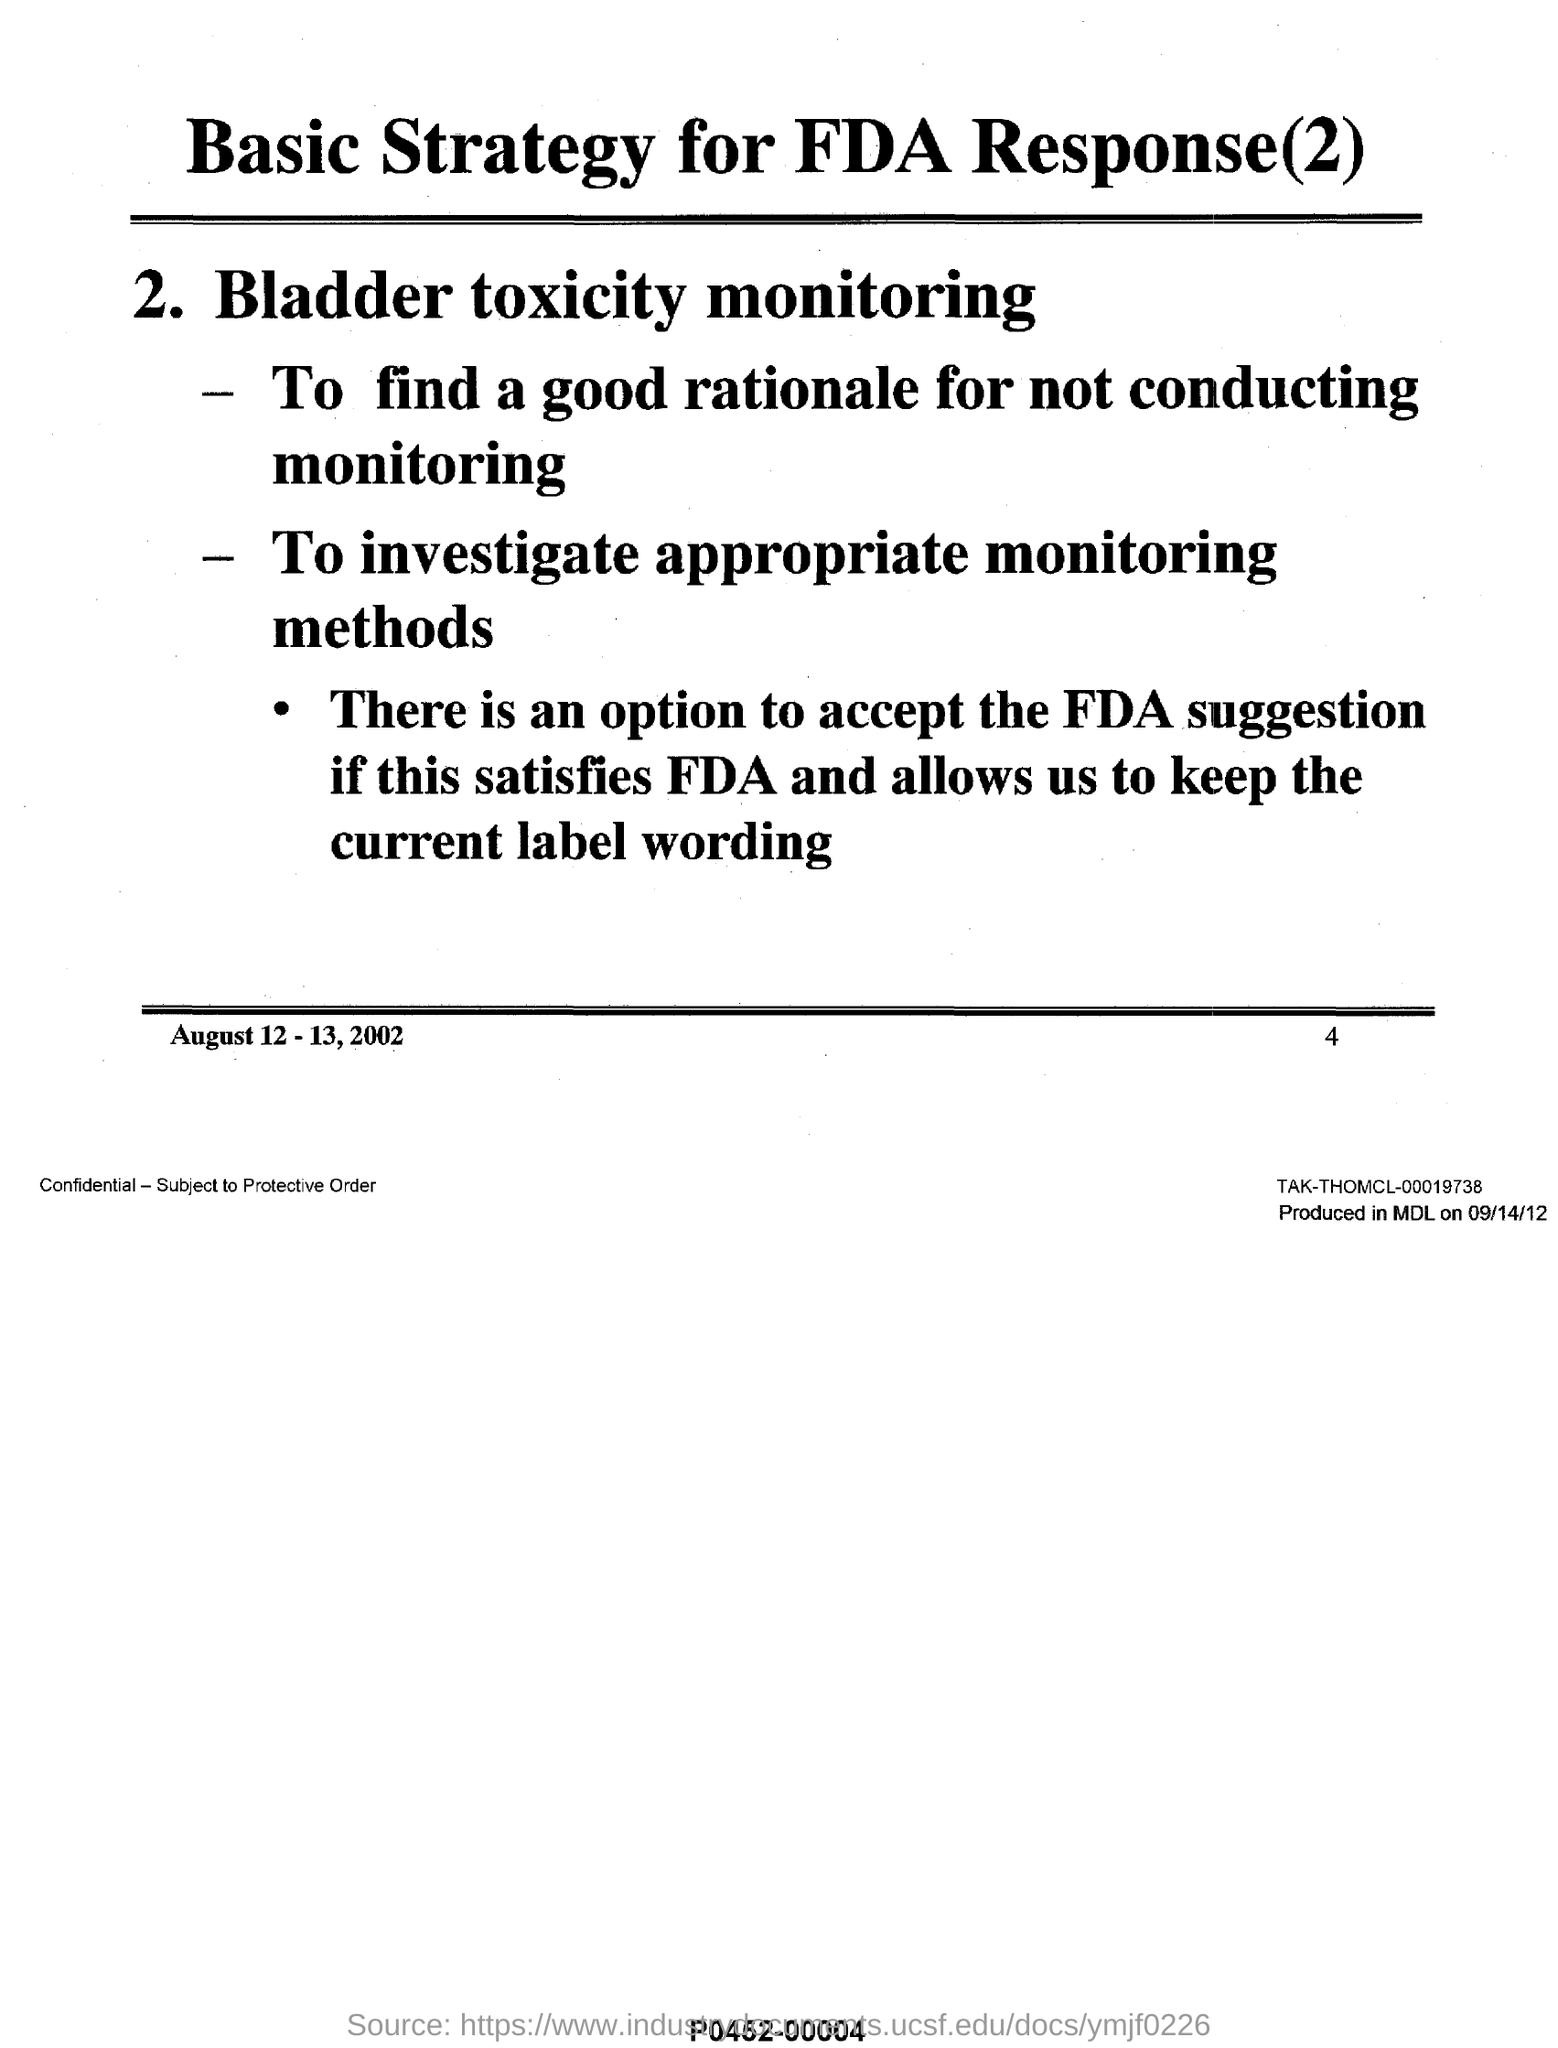What is the second strategy for FDA response?
Make the answer very short. Bladder toxicity monitoring. What is the second purpose of 'bladder toxicity monitoring'?
Your answer should be compact. To investigate appropriate monitoring methods. 